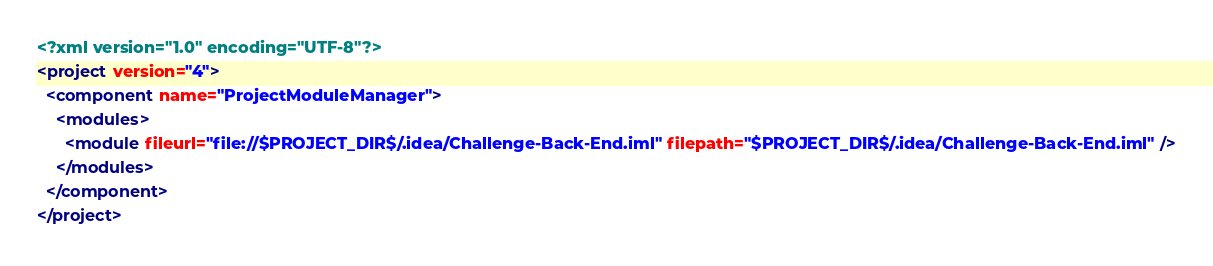<code> <loc_0><loc_0><loc_500><loc_500><_XML_><?xml version="1.0" encoding="UTF-8"?>
<project version="4">
  <component name="ProjectModuleManager">
    <modules>
      <module fileurl="file://$PROJECT_DIR$/.idea/Challenge-Back-End.iml" filepath="$PROJECT_DIR$/.idea/Challenge-Back-End.iml" />
    </modules>
  </component>
</project></code> 